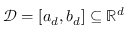Convert formula to latex. <formula><loc_0><loc_0><loc_500><loc_500>\mathcal { D } = [ a _ { d } , b _ { d } ] \subseteq \mathbb { R } ^ { d }</formula> 